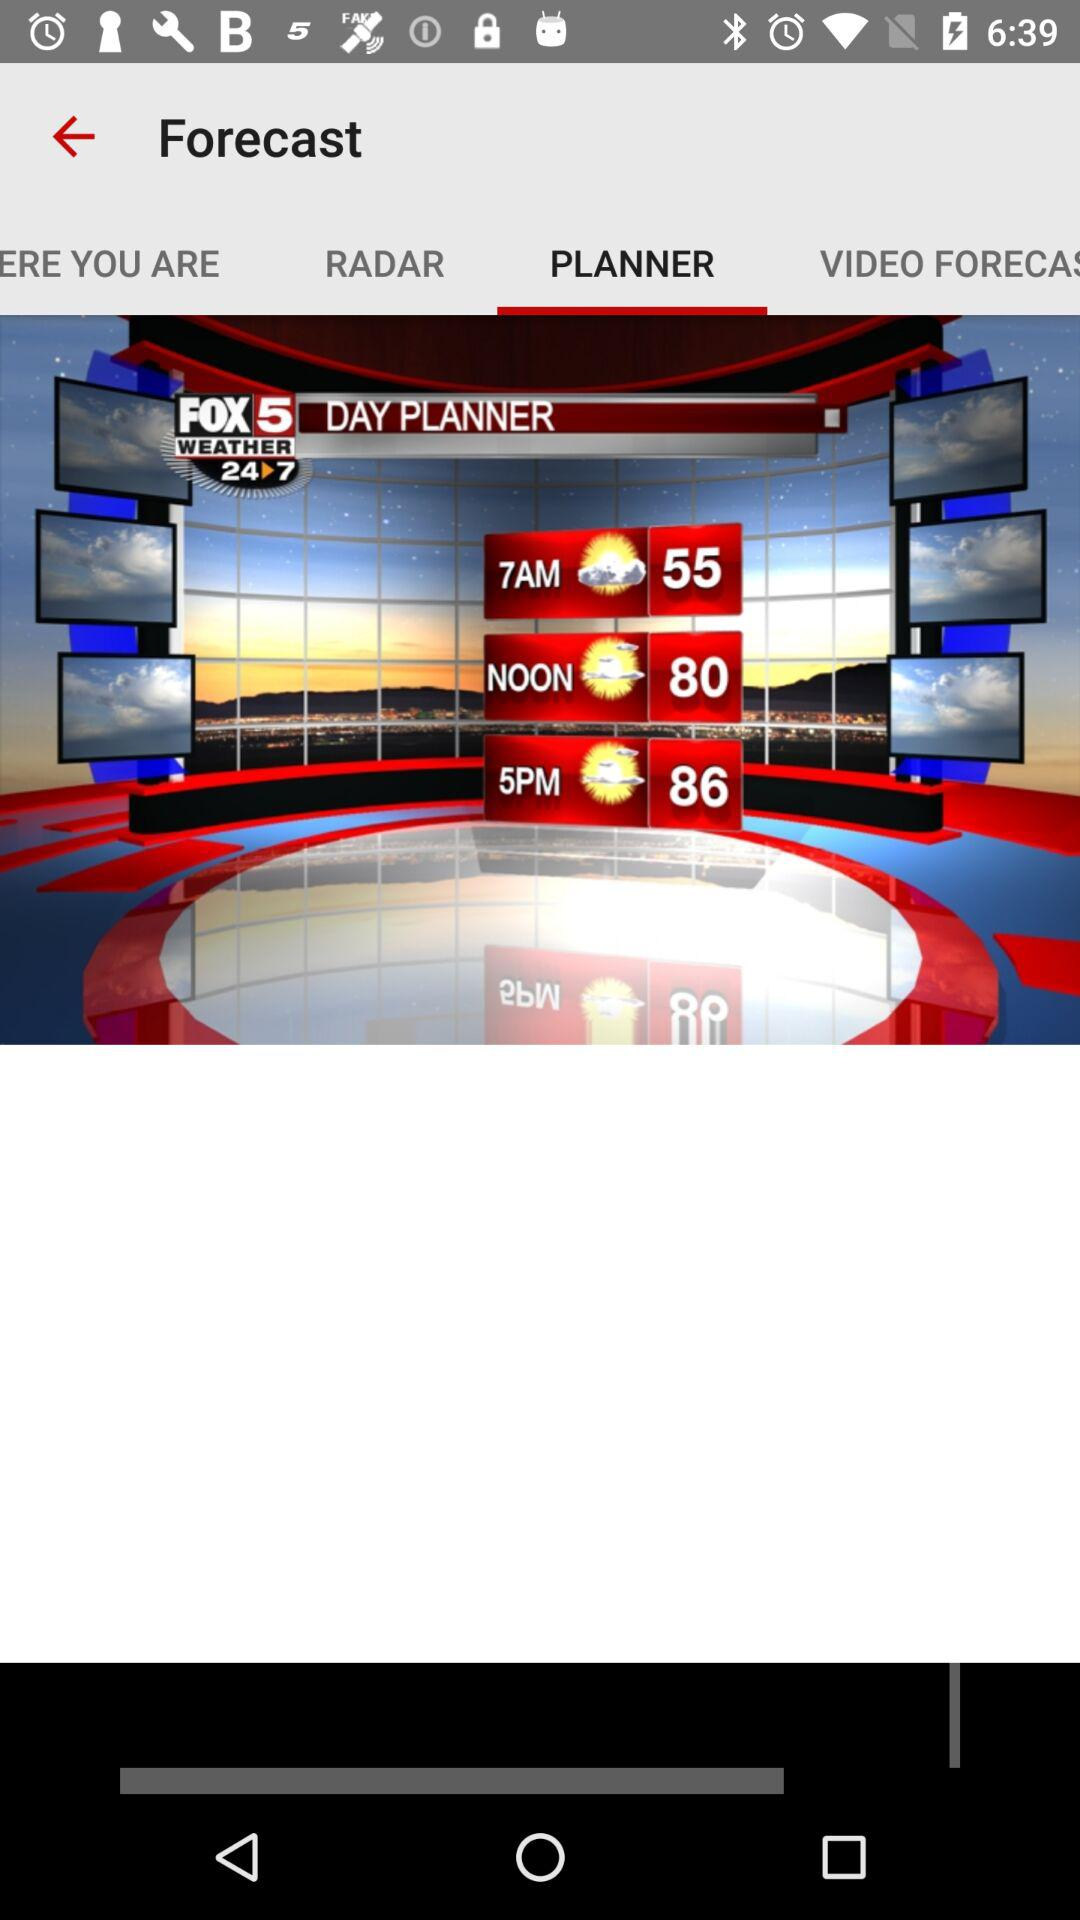How many degrees Fahrenheit is the difference between the temperature at 7am and 5pm?
Answer the question using a single word or phrase. 31 